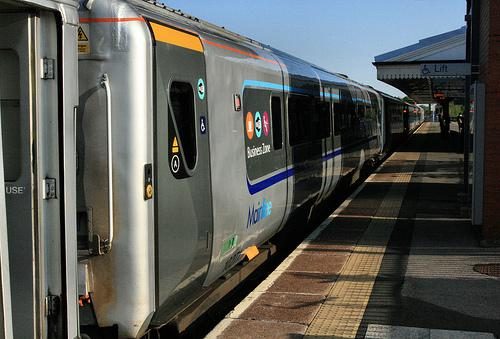Question: what color in the train?
Choices:
A. Silver.
B. Gold.
C. Black.
D. Red.
Answer with the letter. Answer: A Question: where is the train stopped?
Choices:
A. Just short of the station.
B. At the station.
C. Before the crossing.
D. At the peak of the mountain.
Answer with the letter. Answer: B Question: who rides the train?
Choices:
A. Conductor.
B. People.
C. Passengers.
D. Driver.
Answer with the letter. Answer: C Question: when is the photo taken?
Choices:
A. In the nighttime.
B. In the daytime.
C. At sunrise.
D. At sunset.
Answer with the letter. Answer: B Question: what does the sign say on the building?
Choices:
A. Do not enter.
B. No parking.
C. Entrance.
D. Lift.
Answer with the letter. Answer: D 